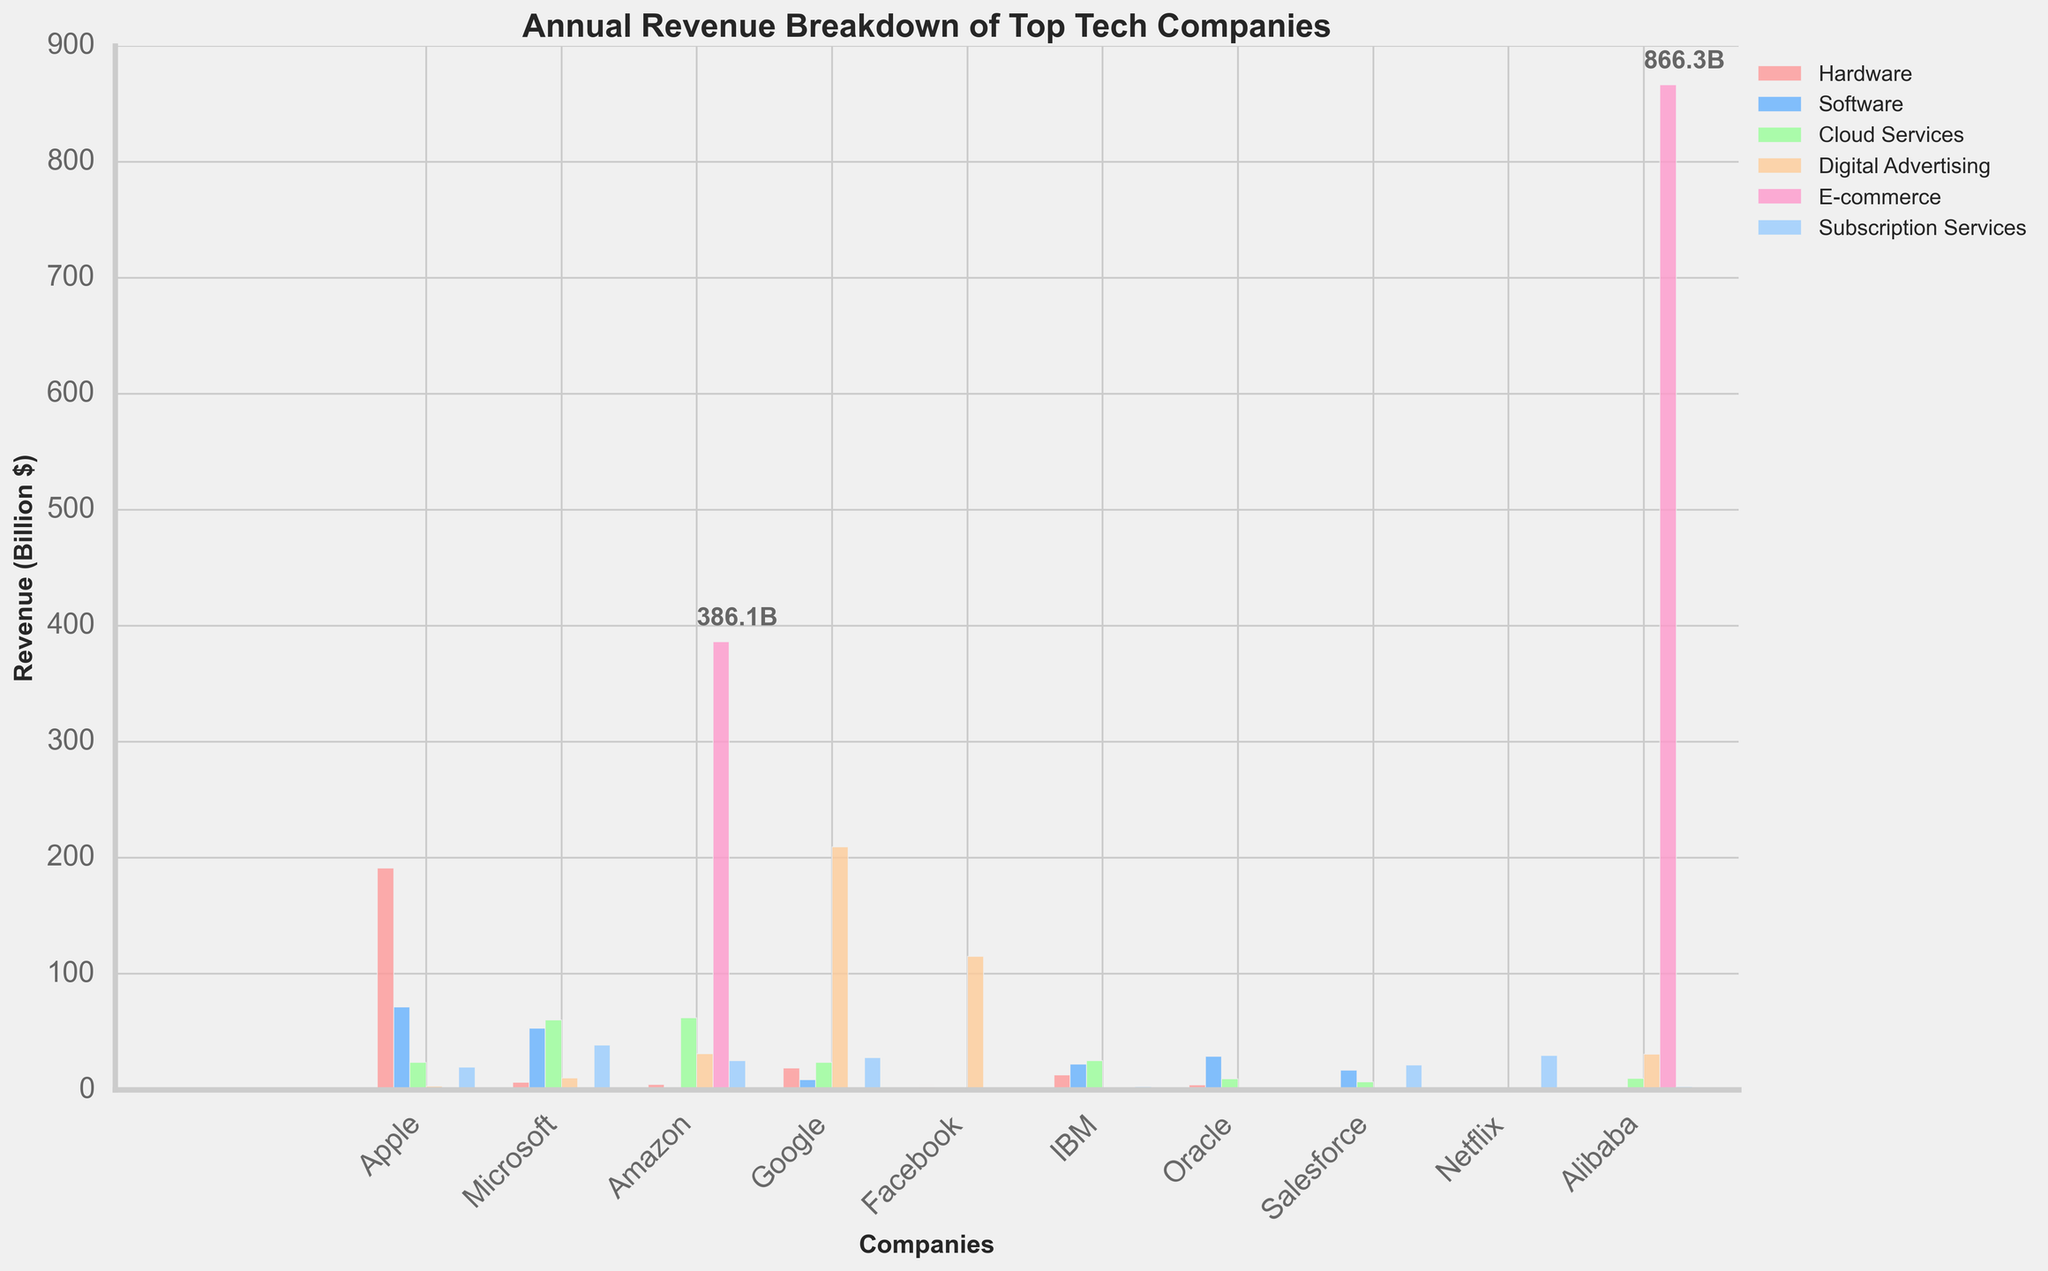Which company has the highest revenue from digital advertising? To find the company with the highest revenue from digital advertising, look for the tallest bar in the 'Digital Advertising' category, which is shown in orange. Google has the highest orange bar.
Answer: Google Which product/service category contributes most to Amazon's revenue? For Amazon, check the category with the tallest bar. The tallest bar for Amazon is in the 'E-commerce' category.
Answer: E-commerce What is the sum of Apple's revenue from hardware and software? Add Apple's revenue from hardware (191.2 billion) and software (71.3 billion). The sum is 191.2 + 71.3 = 262.5.
Answer: 262.5 billion Compare the revenue from cloud services between Microsoft and IBM. Which one is higher and by how much? Microsoft has a cloud services revenue of 60.1 billion, and IBM has 25.1 billion. The difference is 60.1 - 25.1 = 35 billion. Microsoft’s revenue is higher by 35 billion.
Answer: Microsoft by 35 billion What are the two largest sources of revenue for Microsoft? For Microsoft, check the two tallest bars. The tallest bars are for 'Cloud Services' and 'Subscription Services'.
Answer: Cloud Services and Subscription Services How does the revenue from hardware for Apple compare to that of Google? Compare the height of the bars in the 'Hardware' category for Apple and Google. Apple's hardware revenue is higher (191.2 billion) compared to Google's (18.9 billion).
Answer: Apple has higher revenue What is the total revenue for Netflix? Add up the revenue bars for Netflix across all categories. Netflix only has revenue in the 'Subscription Services' category (29.7 billion).
Answer: 29.7 billion Which company has the least significant revenue from cloud services? Look for the shortest bar in the 'Cloud Services' category across all companies. Facebook has no bar for cloud services, indicating a revenue of 0.
Answer: Facebook How does Alibaba's e-commerce revenue compare to Amazon's? Compare the height of the bars in the 'E-commerce' category for Alibaba (866.3 billion) and Amazon (386.1 billion). Alibaba’s e-commerce revenue is higher.
Answer: Alibaba has higher revenue Which company generates revenue in the most diverse categories? Check which company has the most bars across different categories. Microsoft has bars in all categories except E-commerce, indicating it generates revenue from the most diverse categories.
Answer: Microsoft 